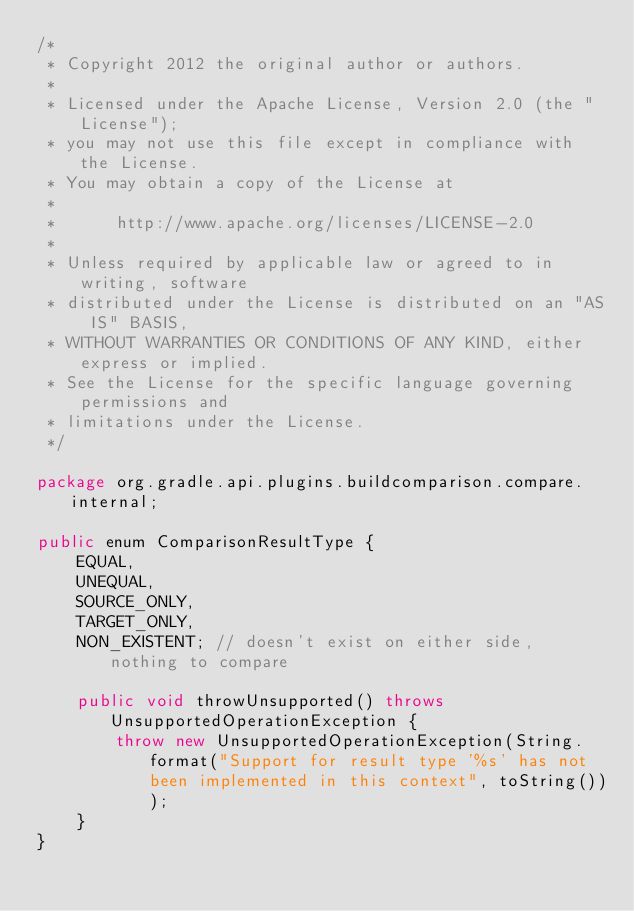<code> <loc_0><loc_0><loc_500><loc_500><_Java_>/*
 * Copyright 2012 the original author or authors.
 *
 * Licensed under the Apache License, Version 2.0 (the "License");
 * you may not use this file except in compliance with the License.
 * You may obtain a copy of the License at
 *
 *      http://www.apache.org/licenses/LICENSE-2.0
 *
 * Unless required by applicable law or agreed to in writing, software
 * distributed under the License is distributed on an "AS IS" BASIS,
 * WITHOUT WARRANTIES OR CONDITIONS OF ANY KIND, either express or implied.
 * See the License for the specific language governing permissions and
 * limitations under the License.
 */

package org.gradle.api.plugins.buildcomparison.compare.internal;

public enum ComparisonResultType {
    EQUAL,
    UNEQUAL,
    SOURCE_ONLY,
    TARGET_ONLY,
    NON_EXISTENT; // doesn't exist on either side, nothing to compare

    public void throwUnsupported() throws UnsupportedOperationException {
        throw new UnsupportedOperationException(String.format("Support for result type '%s' has not been implemented in this context", toString()));
    }
}
</code> 